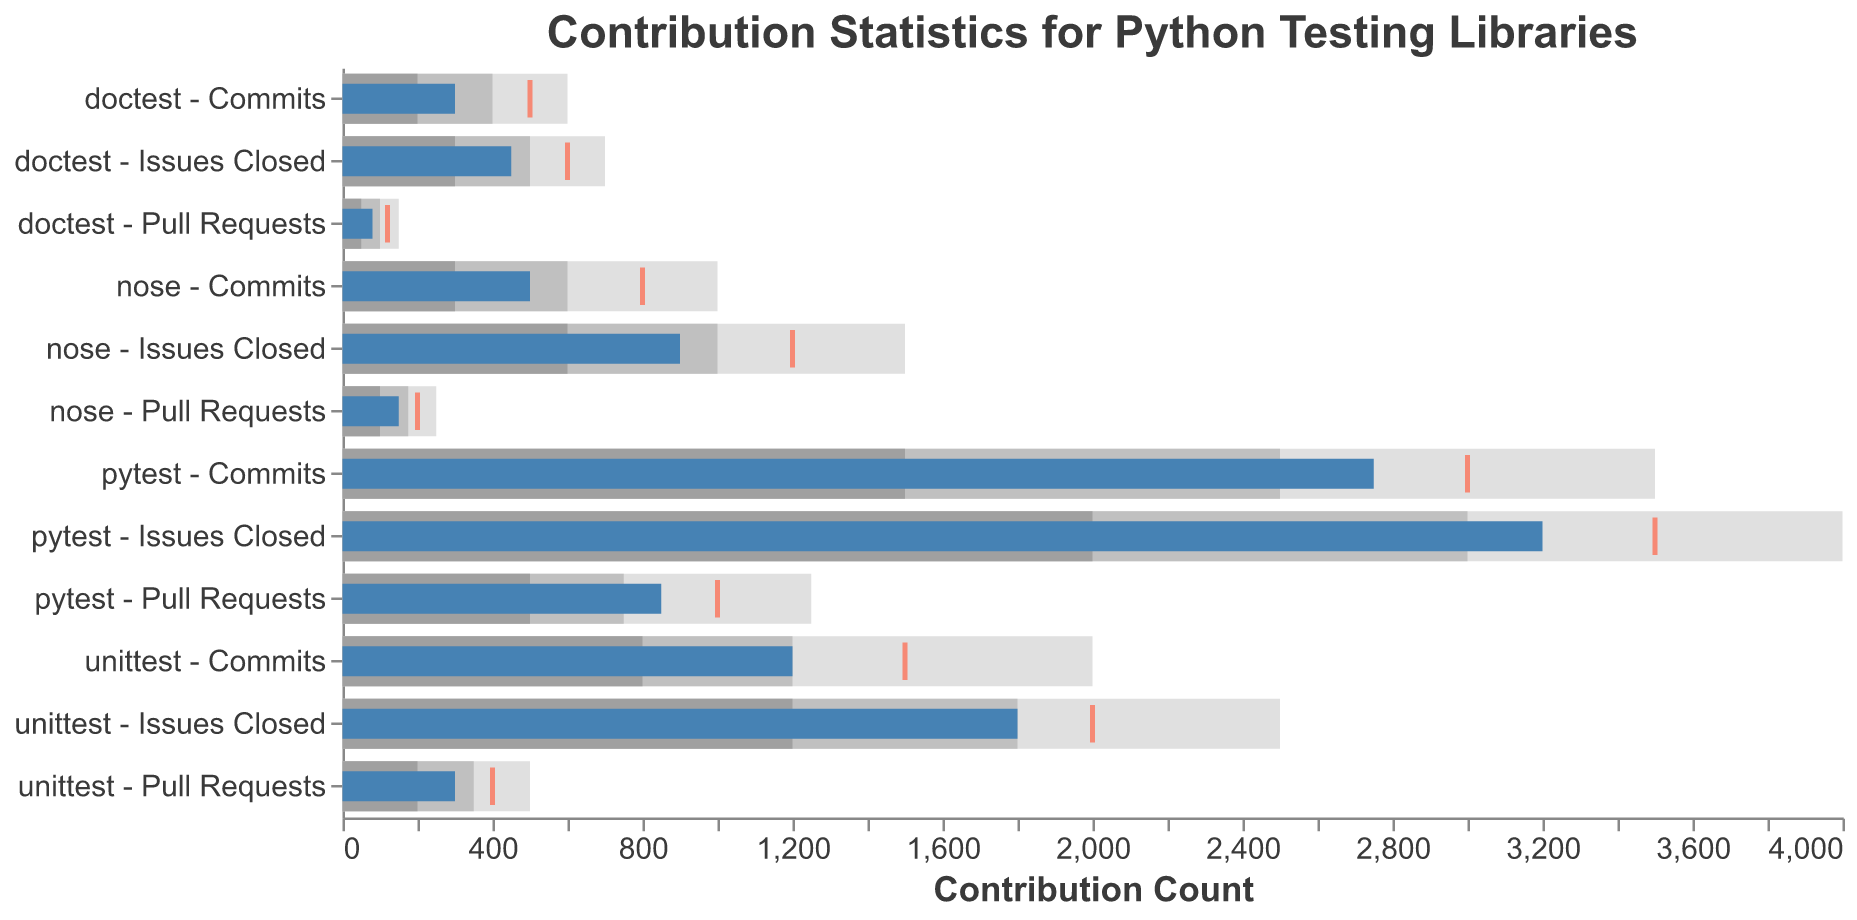Which framework has the highest number of commits? From the bullet chart, 'pytest' has the highest contribution with 2,750 commits. This can be easily seen as the length of the blue bars representing actual values.
Answer: pytest How many issues closed for 'nose' compared to its target? The actual value for 'Issues Closed' in 'nose' is 900, which is 300 less than the target of 1200. This can be inferred by checking the blue bar for actual values against the red tick mark indicating the target.
Answer: 900 What's the difference between the actual and the target for 'unittest' commits? The target for 'unittest' commits is 1500, and the actual value is 1200. The difference is calculated by subtracting the actual from the target: 1500 - 1200 = 300. This can be seen directly by comparing the position of the blue bar and the red tick mark for 'unittest' commits.
Answer: 300 How far is 'doctest' from meeting its pull request target? The actual value for 'doctest' pull requests is 80, and the target is 120. The difference is calculated as 120 - 80 = 40. This is visualized by the gap between the end of the blue bar and the red tick mark in the 'Pull Requests' for 'doctest'.
Answer: 40 Which metric for 'pytest' is closest to its target? The 'Issues Closed' metric for 'pytest' has an actual value of 3200, close to the target of 3500. Comparing the lengths of the blue bars and proximity to the red tick marks for all metrics in 'pytest' shows that the 'Issues Closed' is the most close.
Answer: Issues Closed What is the range of commits considered "excellent" for 'unittest'? According to the bullet chart, the range1 value represents the lower end and the range3 represents the upper end of the excellent range for commits. For 'unittest', this range1 is 800 and range3 is 2000, making the "excellent" range from 800 to 2000 commits. This is illustrated by the color bands, with the leftmost color for inadequate, the middle band for satisfactory, and the rightmost color for excellent.
Answer: 800-2000 Compare the actual and target number of pull requests for 'unittest'. How do they relate? The actual value for 'unittest' pull requests is 300 and the target is 400. Since 300 is less than 400, 'unittest' has not met its target for the pull requests as indicated by the length of the blue bar falling short of the red tick mark in 'Pull Requests' for 'unittest'.
Answer: 300 is less than 400 What is commended as "poor performance" range for 'doctest' commits? In the bullet chart, the "poor performance" range is indicated by the first range measure. For 'doctest' commits, this range1 is 200. Therefore, anything less than 200 commits is considered poor performance. This is shown by the initial color band before 200 for 'doctest' commits in the chart.
Answer: Less than 200 Considering the actual values, which metric did 'unittest' perform best in? Detailed comparison shows that for 'unittest', the Issues Closed metric has the highest actual value at 1800. Comparing the blue bars for actual values of 'unittest' indicates this.
Answer: Issues Closed What aggregate metric is the weakest across all frameworks? Evaluating actual values across all frameworks and metrics, the weakest performance is in 'doctest' pull requests with only 80 actual results. This can be confirmed by comparing the length of all blue bars for different metrics and frameworks.
Answer: Pull Requests in doctest 